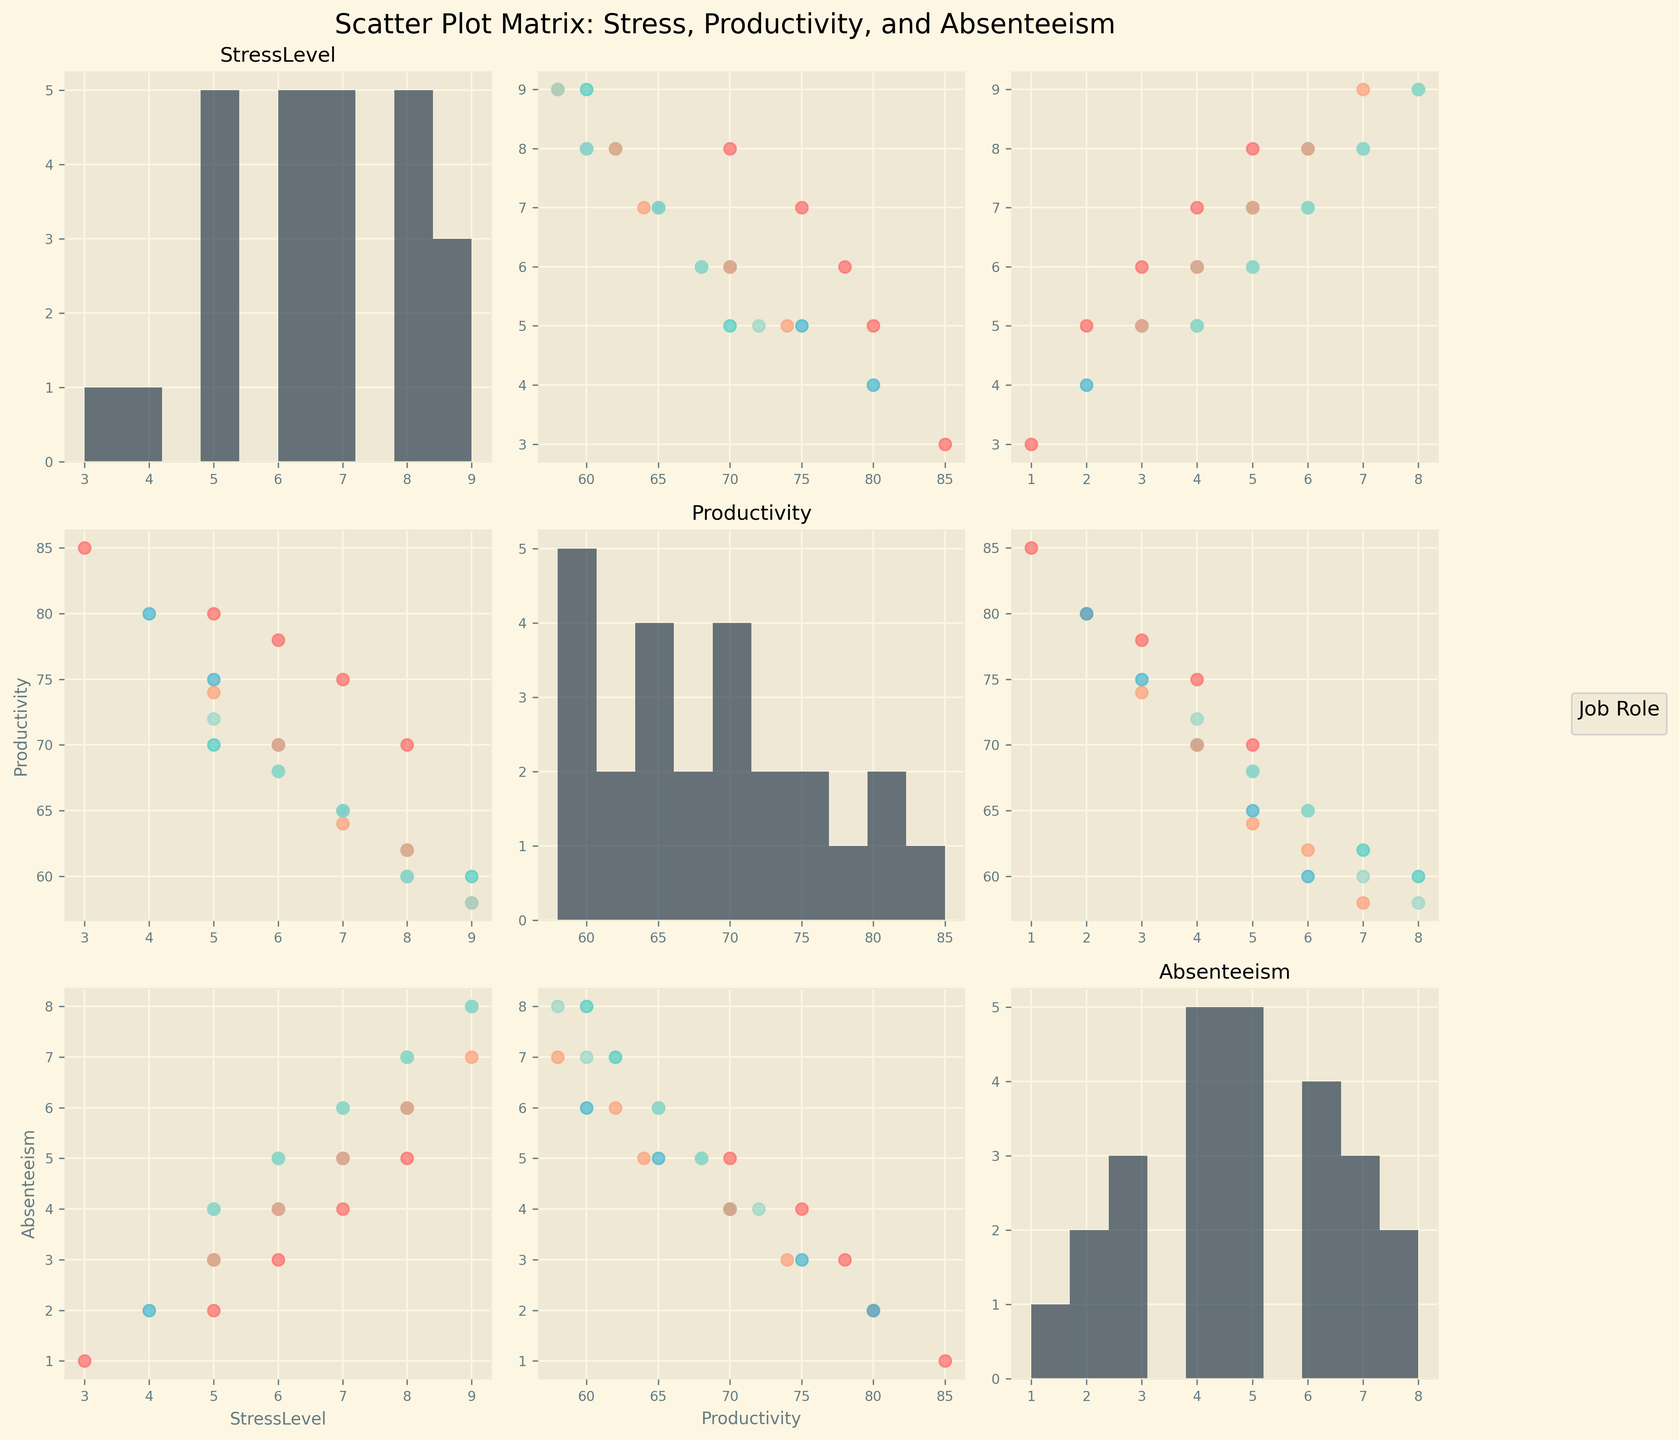What colors represent each job role? The colors are shown in the scatter plot legend on the right side of the figure: Software Engineer is red, Nurse is teal, Sales Representative is light blue, Customer Service is salmon, and Teacher is mint green.
Answer: Red, teal, light blue, salmon, mint green Which job role has the highest absenteeism? By looking at the scatter plots comparing Absenteeism and any other variable, we can observe that Nurses and Teachers have the highest data points for absenteeism, with a value of 8.
Answer: Nurses and Teachers Do higher stress levels generally correlate with lower productivity? By examining the scatter plots between StressLevel and Productivity, we observe a general trend where higher StressLevel points (to the right) tend to show lower Productivity values (lower down).
Answer: Yes What job role shows the least absenteeism at lower stress levels? By examining the scatter plots of StressLevel vs Absenteeism, Software Engineers have lower absenteeism data points (1 or 2) with lower stress levels (3 or 5).
Answer: Software Engineers Which variable appears to have a histogram centered around the median value? In the diagonal histograms showing the distribution for each variable, Productivity's histogram seems to have a more symmetric distribution centered around its median value near 70-75.
Answer: Productivity How does absenteeism differ among job roles with similar stress levels of 7? By comparing the scatter points horizontally at StressLevel 7 on the StressLevel vs Absenteeism plots, the absenteeism varies, with Software Engineers and Customer Service around 5, Nurses around 6, and Teachers around 6.
Answer: Different ranges, with Software Engineers and Customer Service around 5, Nurses around 6, and Teachers around 6 Between Nurses and Sales Representatives, which role has higher productivity at stress levels of 6? By comparing the vertical scatter points at StressLevel 6 on the StressLevel vs Productivity plot, Sales Representatives generally show higher Productivity values around 70-75, whereas Nurses show lower values around 68.
Answer: Sales Representatives What is the primary range of absenteeism for Customer Service roles? Observing the scatter plot points involving CustomerService across all Absenteeism plots, the primary range is between 4 to 7 days.
Answer: 4 to 7 days Is it evident that higher stress levels lead to higher absenteeism across all job roles? By examining the scatter plots comparing StressLevel and Absenteeism, higher stress levels generally correspond to higher absenteeism for most job roles, but there are some exceptions where the correlation is not perfect.
Answer: Generally yes, with some exceptions On average, which job role has the highest productivity when stress levels are less than 6? By examining scatter points at lower StressLevels (≤ 5) in StressLevel vs Productivity plots, Software Engineers and Sales Representatives show higher productivity values, with Software Engineers having values up to 85.
Answer: Software Engineers 